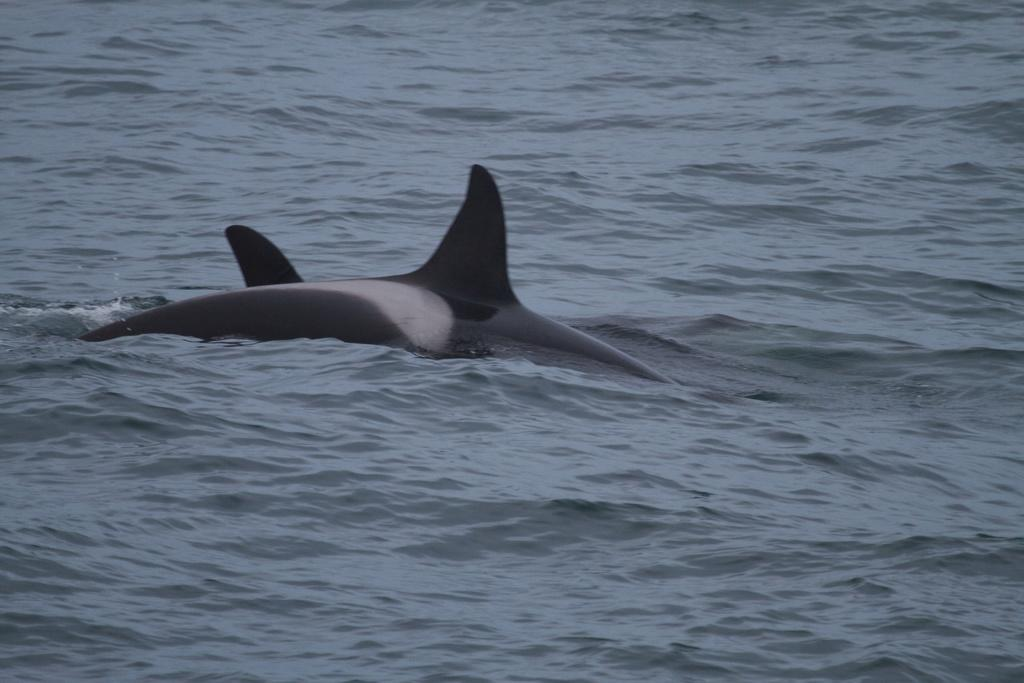What is the main subject in the center of the image? There might be a shark in the center of the image. What type of water body is visible at the bottom of the image? There is a river at the bottom of the image. How much profit does the goldfish generate in the image? There is no goldfish present in the image, so it is not possible to determine any profit generated. 